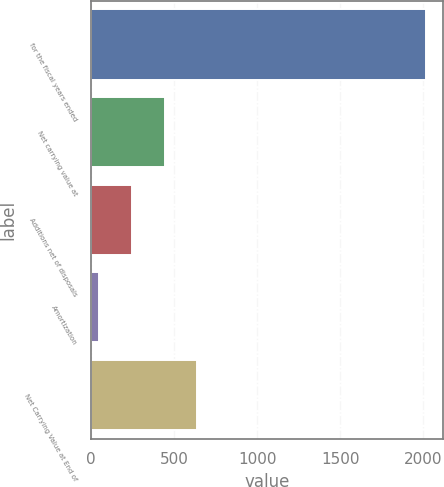<chart> <loc_0><loc_0><loc_500><loc_500><bar_chart><fcel>for the fiscal years ended<fcel>Net carrying value at<fcel>Additions net of disposals<fcel>Amortization<fcel>Net Carrying Value at End of<nl><fcel>2017<fcel>442.68<fcel>245.89<fcel>49.1<fcel>639.47<nl></chart> 